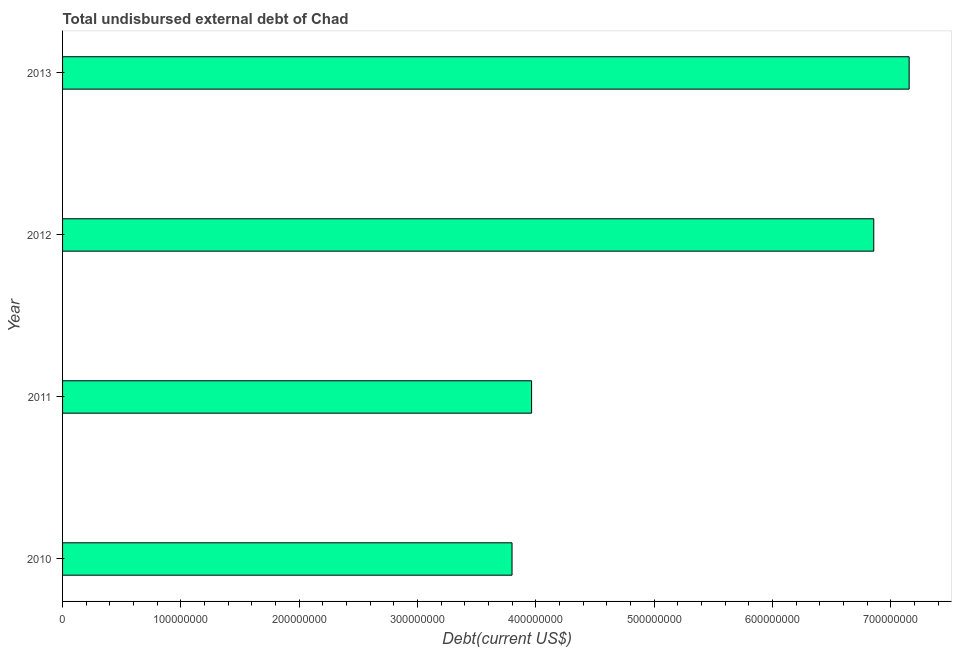Does the graph contain any zero values?
Give a very brief answer. No. Does the graph contain grids?
Your response must be concise. No. What is the title of the graph?
Make the answer very short. Total undisbursed external debt of Chad. What is the label or title of the X-axis?
Offer a terse response. Debt(current US$). What is the label or title of the Y-axis?
Give a very brief answer. Year. What is the total debt in 2010?
Your answer should be compact. 3.80e+08. Across all years, what is the maximum total debt?
Your response must be concise. 7.15e+08. Across all years, what is the minimum total debt?
Give a very brief answer. 3.80e+08. In which year was the total debt minimum?
Provide a short and direct response. 2010. What is the sum of the total debt?
Your response must be concise. 2.18e+09. What is the difference between the total debt in 2010 and 2011?
Keep it short and to the point. -1.65e+07. What is the average total debt per year?
Your answer should be compact. 5.44e+08. What is the median total debt?
Give a very brief answer. 5.41e+08. Do a majority of the years between 2011 and 2010 (inclusive) have total debt greater than 560000000 US$?
Your response must be concise. No. What is the ratio of the total debt in 2010 to that in 2011?
Your answer should be compact. 0.96. Is the difference between the total debt in 2010 and 2011 greater than the difference between any two years?
Make the answer very short. No. What is the difference between the highest and the second highest total debt?
Your answer should be very brief. 2.99e+07. Is the sum of the total debt in 2011 and 2012 greater than the maximum total debt across all years?
Your answer should be compact. Yes. What is the difference between the highest and the lowest total debt?
Give a very brief answer. 3.36e+08. In how many years, is the total debt greater than the average total debt taken over all years?
Give a very brief answer. 2. How many bars are there?
Provide a short and direct response. 4. Are all the bars in the graph horizontal?
Give a very brief answer. Yes. How many years are there in the graph?
Ensure brevity in your answer.  4. Are the values on the major ticks of X-axis written in scientific E-notation?
Give a very brief answer. No. What is the Debt(current US$) in 2010?
Offer a very short reply. 3.80e+08. What is the Debt(current US$) in 2011?
Your answer should be compact. 3.96e+08. What is the Debt(current US$) of 2012?
Offer a terse response. 6.86e+08. What is the Debt(current US$) of 2013?
Keep it short and to the point. 7.15e+08. What is the difference between the Debt(current US$) in 2010 and 2011?
Give a very brief answer. -1.65e+07. What is the difference between the Debt(current US$) in 2010 and 2012?
Give a very brief answer. -3.06e+08. What is the difference between the Debt(current US$) in 2010 and 2013?
Your response must be concise. -3.36e+08. What is the difference between the Debt(current US$) in 2011 and 2012?
Offer a very short reply. -2.89e+08. What is the difference between the Debt(current US$) in 2011 and 2013?
Your response must be concise. -3.19e+08. What is the difference between the Debt(current US$) in 2012 and 2013?
Make the answer very short. -2.99e+07. What is the ratio of the Debt(current US$) in 2010 to that in 2011?
Your response must be concise. 0.96. What is the ratio of the Debt(current US$) in 2010 to that in 2012?
Provide a succinct answer. 0.55. What is the ratio of the Debt(current US$) in 2010 to that in 2013?
Offer a terse response. 0.53. What is the ratio of the Debt(current US$) in 2011 to that in 2012?
Provide a succinct answer. 0.58. What is the ratio of the Debt(current US$) in 2011 to that in 2013?
Provide a short and direct response. 0.55. What is the ratio of the Debt(current US$) in 2012 to that in 2013?
Offer a very short reply. 0.96. 